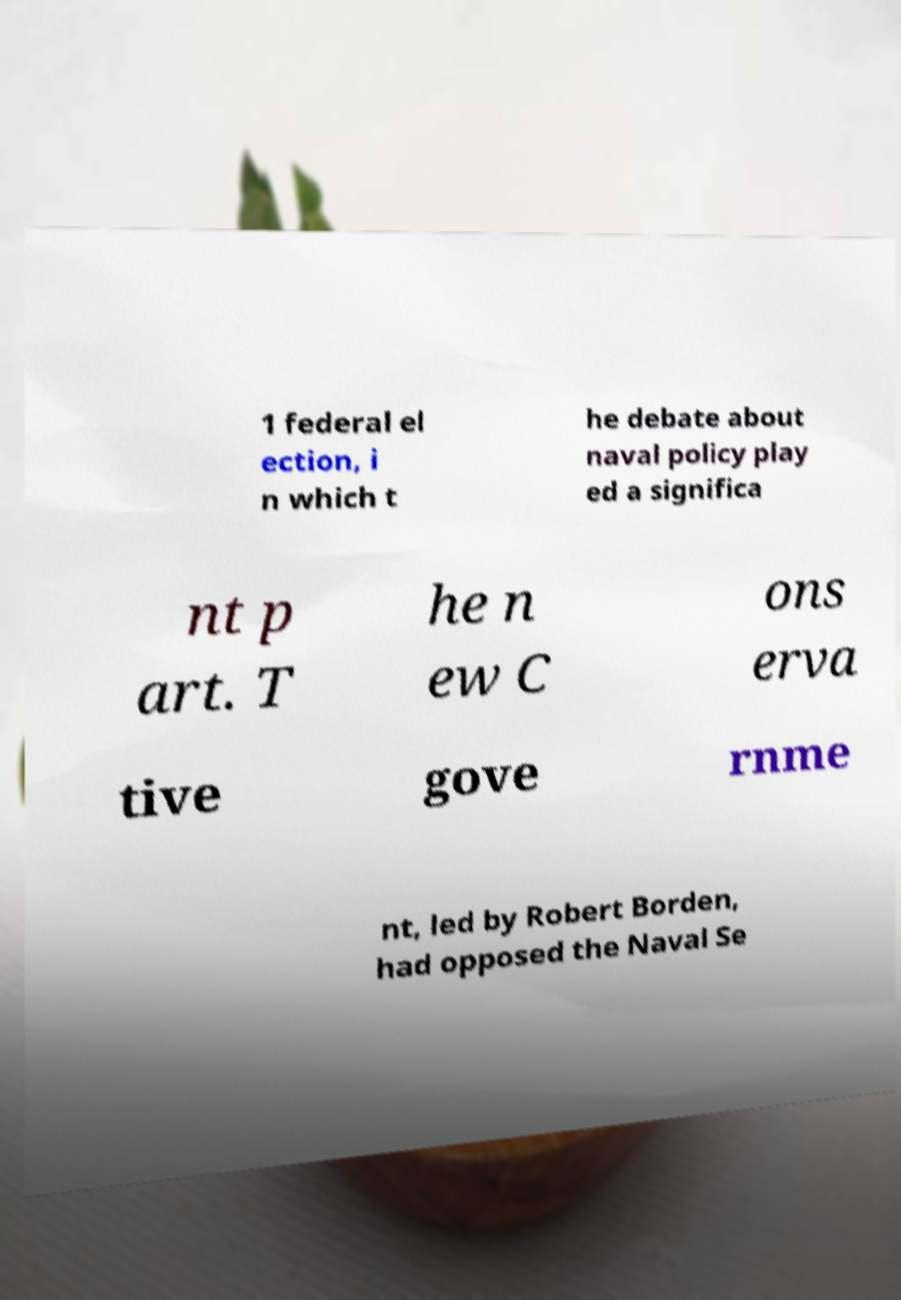Can you accurately transcribe the text from the provided image for me? 1 federal el ection, i n which t he debate about naval policy play ed a significa nt p art. T he n ew C ons erva tive gove rnme nt, led by Robert Borden, had opposed the Naval Se 